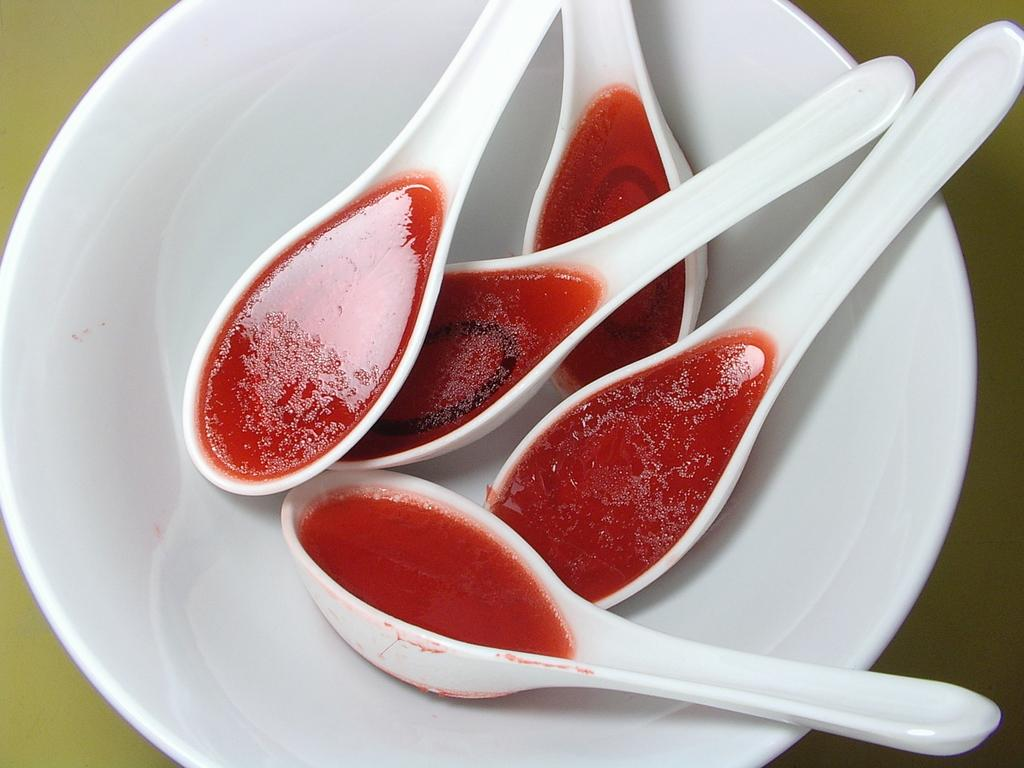How many spoons are visible in the image? There are five white spoons in the image. What is in the spoons? The spoons have something in them. Where are the spoons placed? The spoons are placed in a white bowl. Is the linen visible in the image? There is no linen present in the image. What type of action is the quicksand performing in the image? There is no quicksand present in the image, so it cannot perform any actions. 